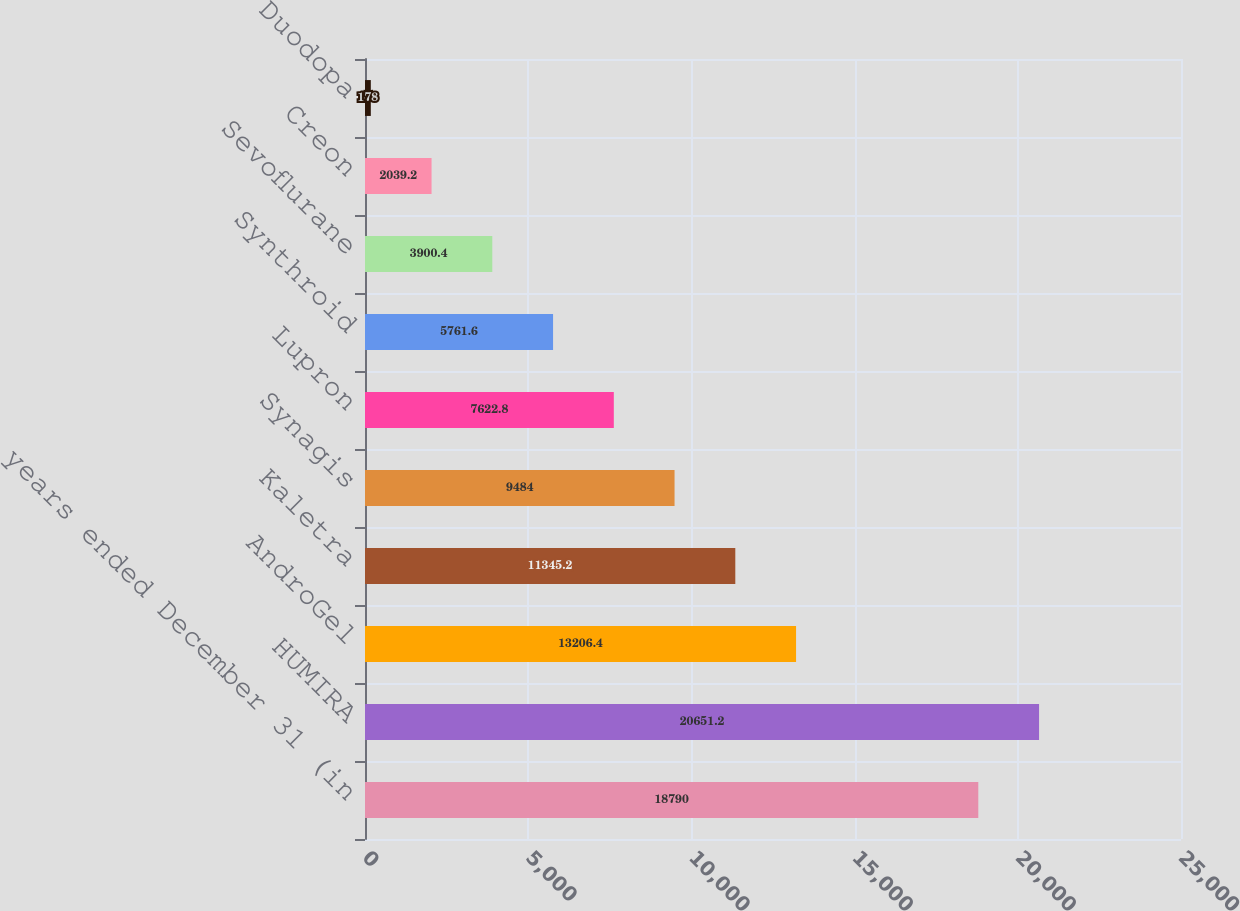<chart> <loc_0><loc_0><loc_500><loc_500><bar_chart><fcel>years ended December 31 (in<fcel>HUMIRA<fcel>AndroGel<fcel>Kaletra<fcel>Synagis<fcel>Lupron<fcel>Synthroid<fcel>Sevoflurane<fcel>Creon<fcel>Duodopa<nl><fcel>18790<fcel>20651.2<fcel>13206.4<fcel>11345.2<fcel>9484<fcel>7622.8<fcel>5761.6<fcel>3900.4<fcel>2039.2<fcel>178<nl></chart> 